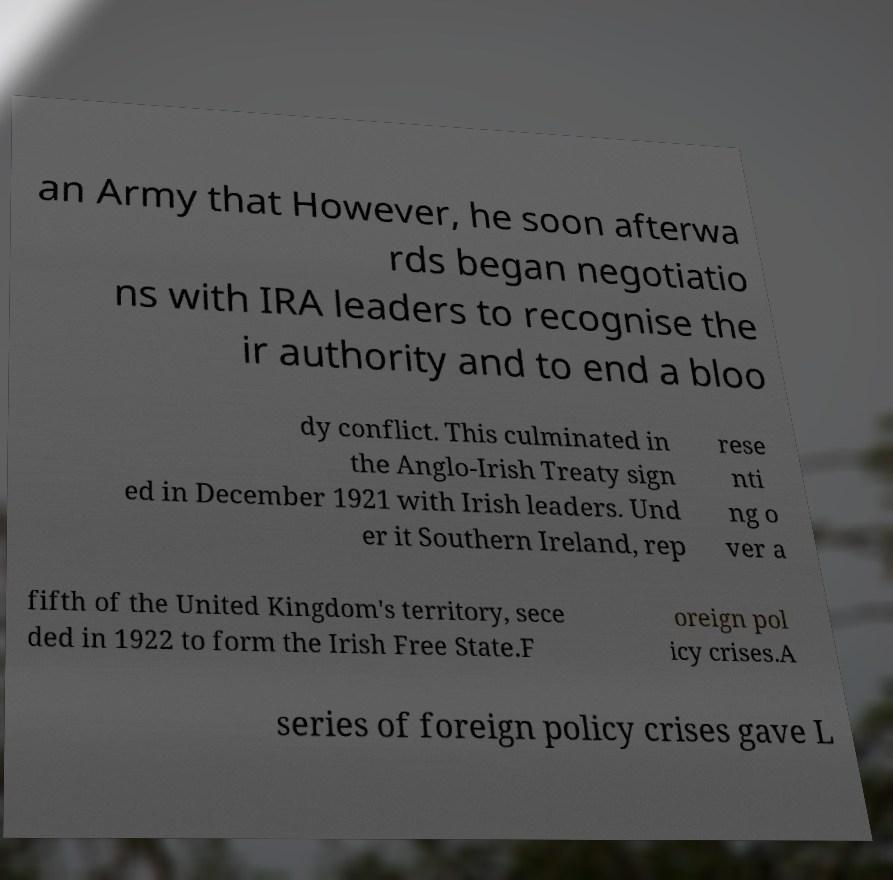I need the written content from this picture converted into text. Can you do that? an Army that However, he soon afterwa rds began negotiatio ns with IRA leaders to recognise the ir authority and to end a bloo dy conflict. This culminated in the Anglo-Irish Treaty sign ed in December 1921 with Irish leaders. Und er it Southern Ireland, rep rese nti ng o ver a fifth of the United Kingdom's territory, sece ded in 1922 to form the Irish Free State.F oreign pol icy crises.A series of foreign policy crises gave L 